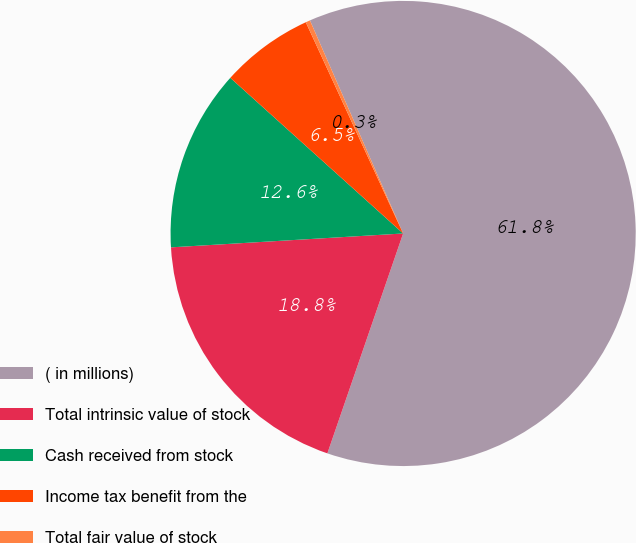Convert chart. <chart><loc_0><loc_0><loc_500><loc_500><pie_chart><fcel>( in millions)<fcel>Total intrinsic value of stock<fcel>Cash received from stock<fcel>Income tax benefit from the<fcel>Total fair value of stock<nl><fcel>61.85%<fcel>18.77%<fcel>12.62%<fcel>6.46%<fcel>0.31%<nl></chart> 